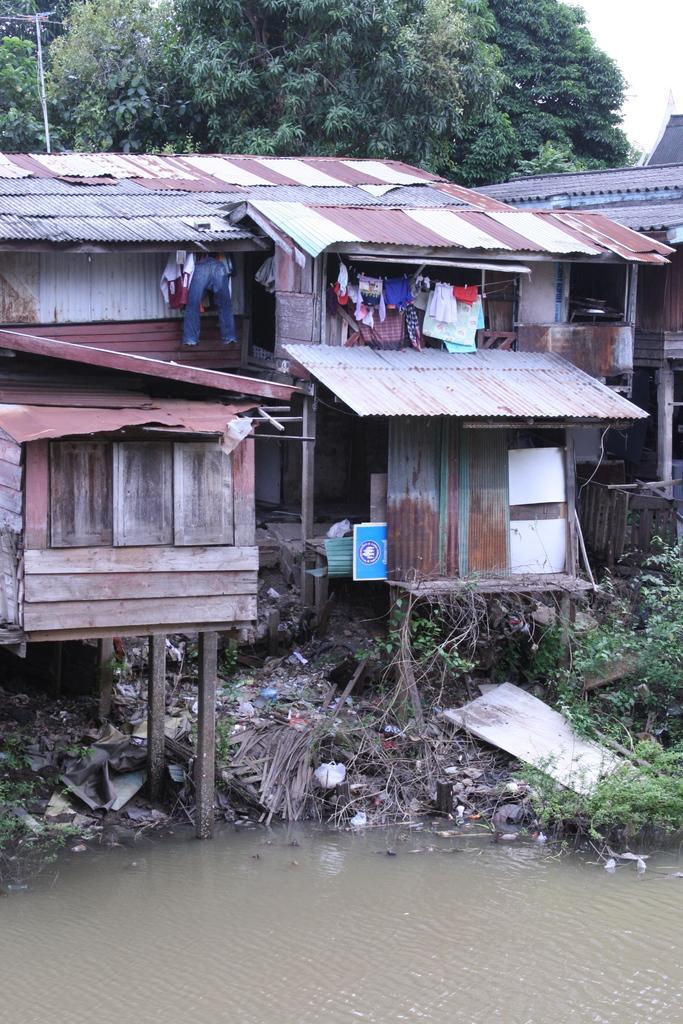Can you describe this image briefly? In the picture we can see some huts under it we can see some garbage and near it we can see water and behind the hats we can see some trees. 